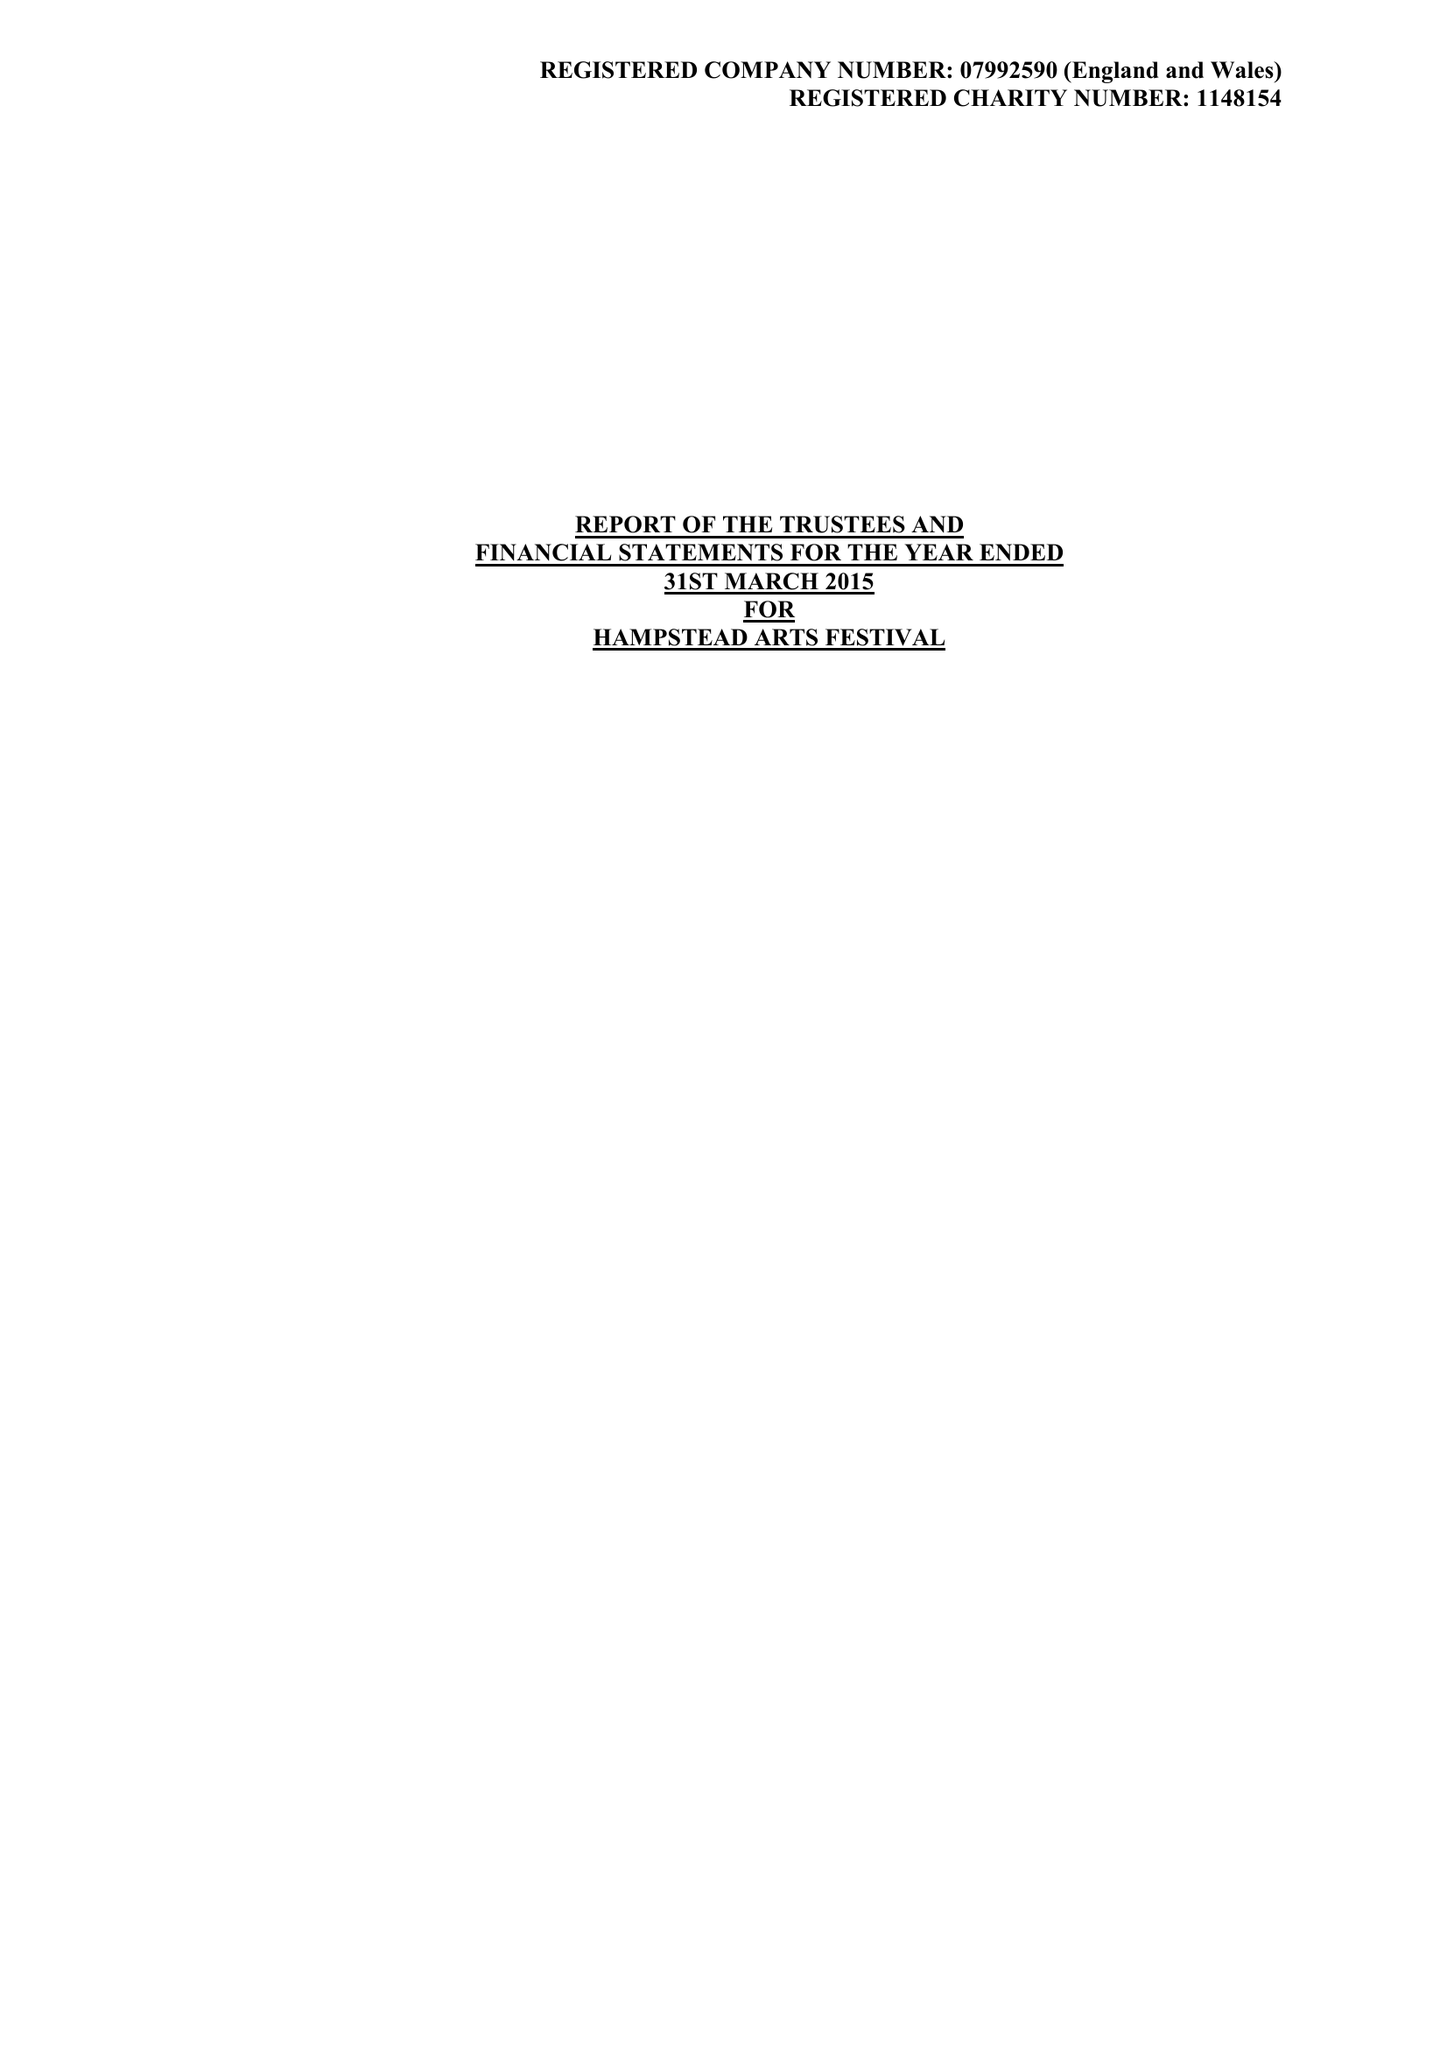What is the value for the spending_annually_in_british_pounds?
Answer the question using a single word or phrase. 33742.00 